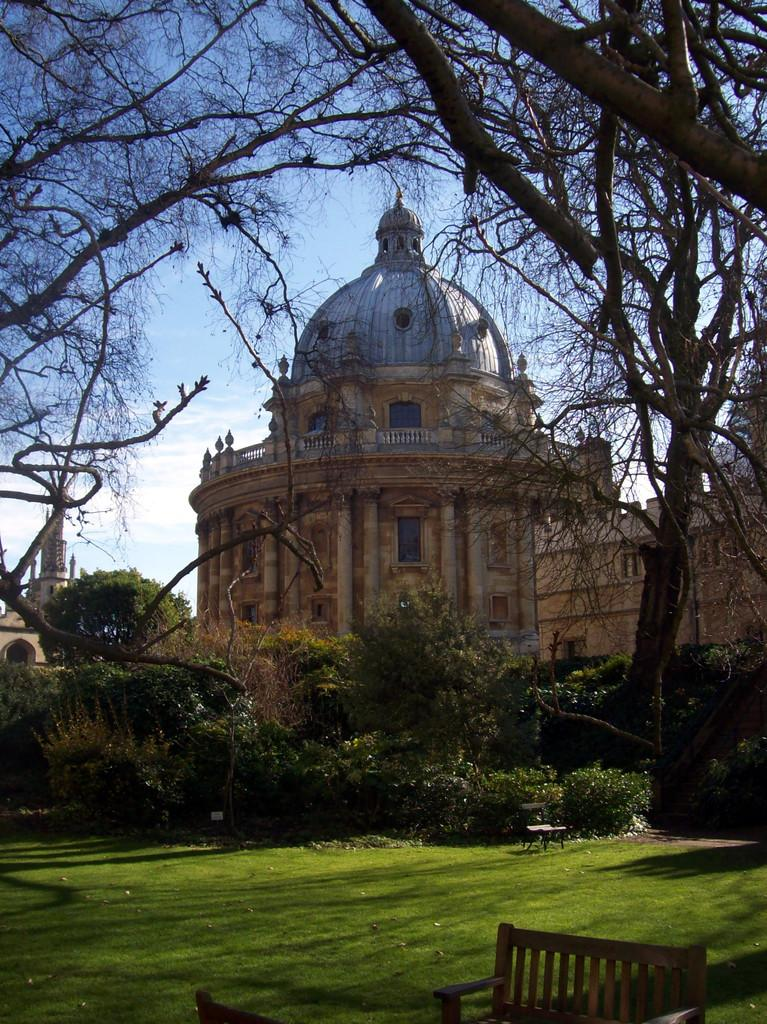What type of vegetation can be seen in the image? There is green grass in the image. How many benches are present in the image? There are 2 benches in the image. What other living organisms can be seen in the image? There are plants in the image. What can be seen in the background of the image? There are trees, buildings, and the sky visible in the background of the image. What type of seed is being planted in the image? There is no seed being planted in the image; it only features green grass, benches, plants, trees, buildings, and a clear sky. 